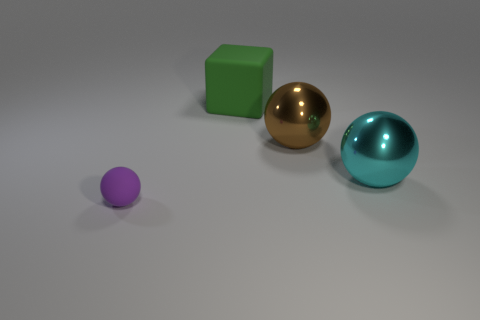Add 4 small matte spheres. How many objects exist? 8 Subtract 1 cubes. How many cubes are left? 0 Subtract 0 green cylinders. How many objects are left? 4 Subtract all cubes. How many objects are left? 3 Subtract all red spheres. Subtract all brown cubes. How many spheres are left? 3 Subtract all gray cubes. How many purple spheres are left? 1 Subtract all small matte things. Subtract all large brown shiny objects. How many objects are left? 2 Add 3 green cubes. How many green cubes are left? 4 Add 2 big metal spheres. How many big metal spheres exist? 4 Subtract all big shiny spheres. How many spheres are left? 1 